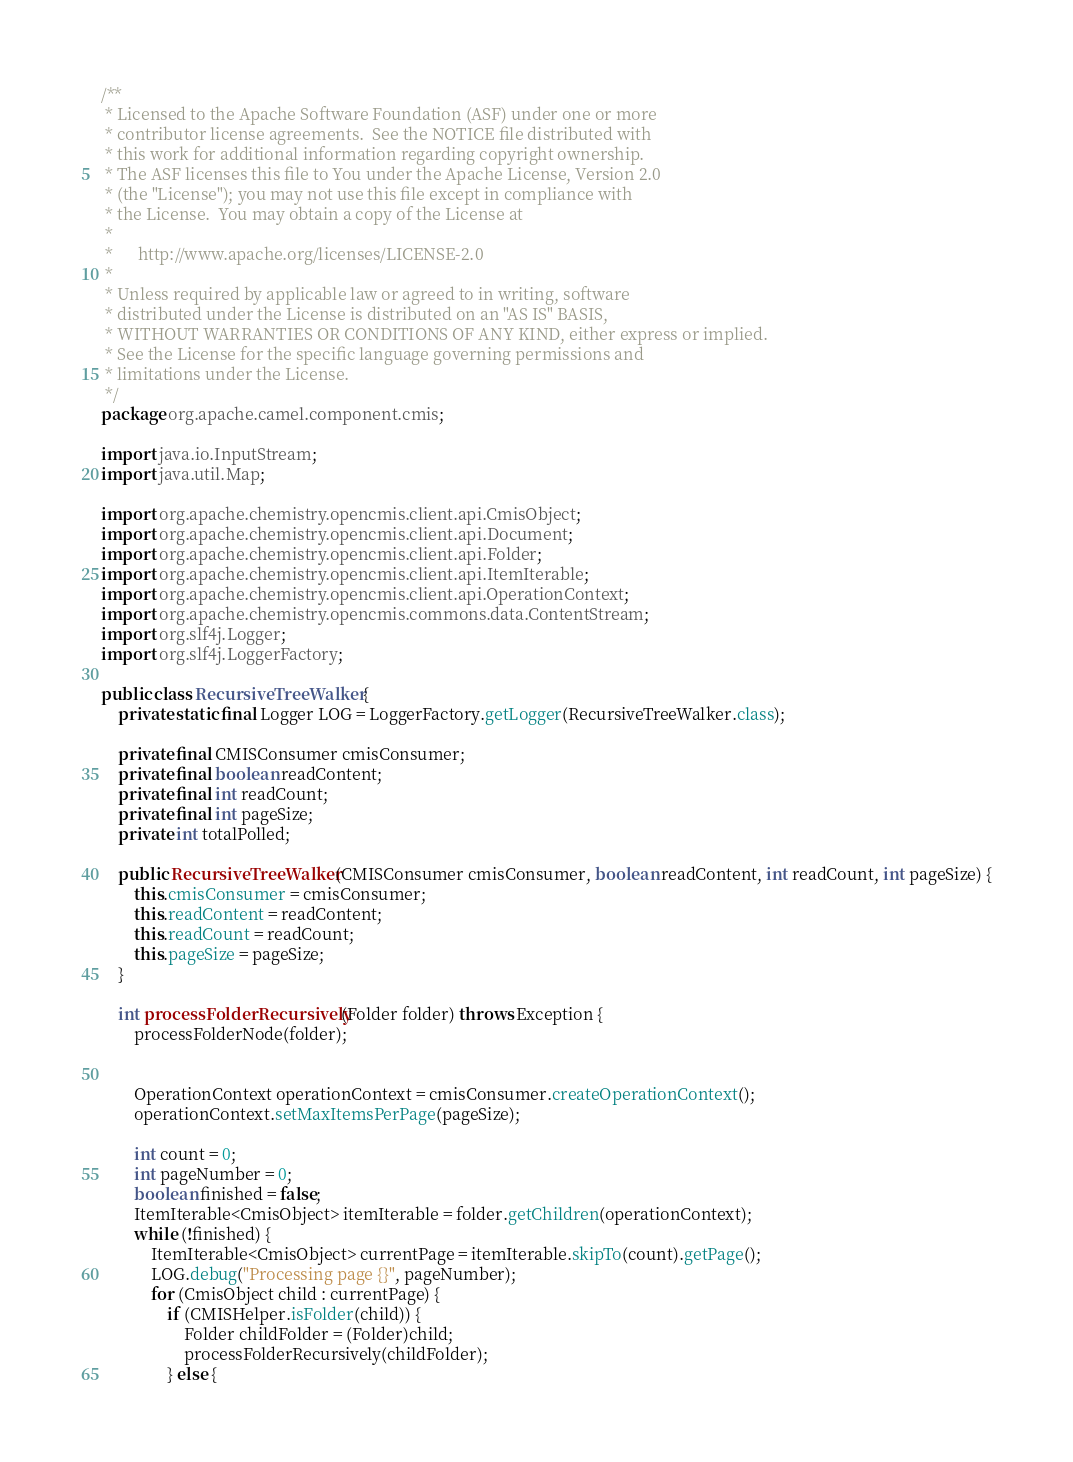<code> <loc_0><loc_0><loc_500><loc_500><_Java_>/**
 * Licensed to the Apache Software Foundation (ASF) under one or more
 * contributor license agreements.  See the NOTICE file distributed with
 * this work for additional information regarding copyright ownership.
 * The ASF licenses this file to You under the Apache License, Version 2.0
 * (the "License"); you may not use this file except in compliance with
 * the License.  You may obtain a copy of the License at
 *
 *      http://www.apache.org/licenses/LICENSE-2.0
 *
 * Unless required by applicable law or agreed to in writing, software
 * distributed under the License is distributed on an "AS IS" BASIS,
 * WITHOUT WARRANTIES OR CONDITIONS OF ANY KIND, either express or implied.
 * See the License for the specific language governing permissions and
 * limitations under the License.
 */
package org.apache.camel.component.cmis;

import java.io.InputStream;
import java.util.Map;

import org.apache.chemistry.opencmis.client.api.CmisObject;
import org.apache.chemistry.opencmis.client.api.Document;
import org.apache.chemistry.opencmis.client.api.Folder;
import org.apache.chemistry.opencmis.client.api.ItemIterable;
import org.apache.chemistry.opencmis.client.api.OperationContext;
import org.apache.chemistry.opencmis.commons.data.ContentStream;
import org.slf4j.Logger;
import org.slf4j.LoggerFactory;

public class RecursiveTreeWalker {
    private static final Logger LOG = LoggerFactory.getLogger(RecursiveTreeWalker.class);

    private final CMISConsumer cmisConsumer;
    private final boolean readContent;
    private final int readCount;
    private final int pageSize;
    private int totalPolled;

    public RecursiveTreeWalker(CMISConsumer cmisConsumer, boolean readContent, int readCount, int pageSize) {
        this.cmisConsumer = cmisConsumer;
        this.readContent = readContent;
        this.readCount = readCount;
        this.pageSize = pageSize;
    }

    int processFolderRecursively(Folder folder) throws Exception {
        processFolderNode(folder);

        
        OperationContext operationContext = cmisConsumer.createOperationContext();
        operationContext.setMaxItemsPerPage(pageSize);

        int count = 0;
        int pageNumber = 0;
        boolean finished = false;
        ItemIterable<CmisObject> itemIterable = folder.getChildren(operationContext);
        while (!finished) {
            ItemIterable<CmisObject> currentPage = itemIterable.skipTo(count).getPage();
            LOG.debug("Processing page {}", pageNumber);
            for (CmisObject child : currentPage) {
                if (CMISHelper.isFolder(child)) {
                    Folder childFolder = (Folder)child;
                    processFolderRecursively(childFolder);
                } else {</code> 